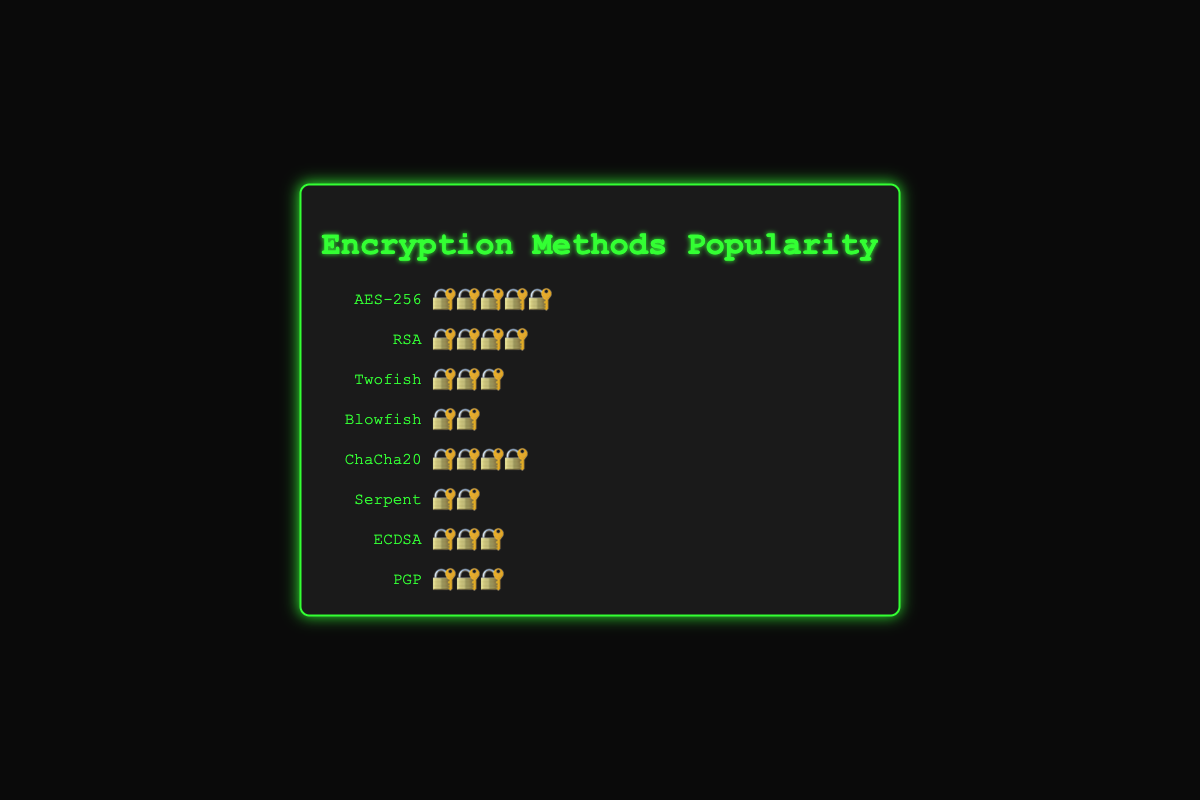Which encryption method is the most popular? The figure shows that the encryption method with the most 🔐 symbols is AES-256, which has 5 🔐 symbols, indicating it is the most popular.
Answer: AES-256 How many encryption methods have a popularity rating of 3? The methods Twofish, ECDSA, and PGP all have 3 🔐 symbols each. Count these methods to get the answer.
Answer: 3 Which two encryption methods have the same popularity rating of 4? The figure shows both RSA and ChaCha20 have 4 🔐 symbols.
Answer: RSA and ChaCha20 What is the total sum of popularity ratings for all methods? Sum the popularity ratings for each encryption method: 5 (AES-256) + 4 (RSA) + 3 (Twofish) + 2 (Blowfish) + 4 (ChaCha20) + 2 (Serpent) + 3 (ECDSA) + 3 (PGP) = 26.
Answer: 26 Which encryption method has the least popularity, and what is its rating? The figure shows Blowfish and Serpent both have 2 🔐 symbols, the least number of symbols of all methods.
Answer: Blowfish and Serpent Is the combined popularity of ECDSA and PGP greater than the popularity of AES-256? The popularity of ECDSA is 3 and PGP is 3, combined they are 3 + 3 = 6. AES-256 has a popularity of 5. Since 6 is greater than 5, the combined popularity is greater.
Answer: Yes What is the average popularity rating across all methods? The total sum of popularity ratings is 26, and there are 8 methods. 26 divided by 8 is 3.25.
Answer: 3.25 How does the popularity of Twofish compare to Serpent? Twofish has 3 🔐 symbols while Serpent has 2 🔐 symbols. Therefore, Twofish is more popular than Serpent.
Answer: More popular 